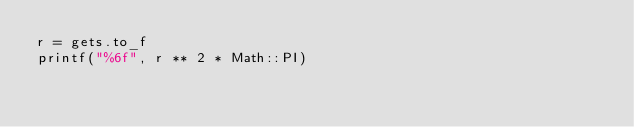<code> <loc_0><loc_0><loc_500><loc_500><_Ruby_>r = gets.to_f
printf("%6f", r ** 2 * Math::PI)</code> 